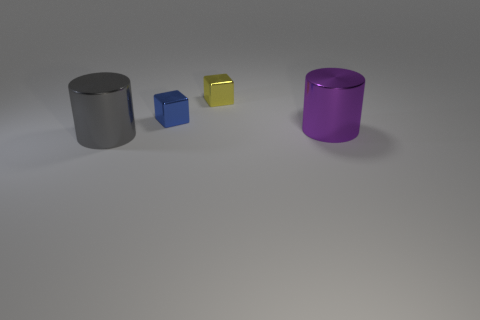What shape is the thing that is behind the big gray metallic thing and on the left side of the yellow cube?
Your answer should be very brief. Cube. There is a large metal object that is to the left of the blue shiny block; is it the same shape as the large metallic thing that is to the right of the blue thing?
Keep it short and to the point. Yes. What number of spheres are either big purple rubber things or purple things?
Offer a very short reply. 0. Is the number of yellow objects left of the tiny yellow block less than the number of big red balls?
Make the answer very short. No. How many other things are made of the same material as the gray thing?
Your response must be concise. 3. Does the gray object have the same size as the purple object?
Offer a terse response. Yes. What number of objects are large shiny cylinders that are left of the blue metal cube or big yellow rubber cubes?
Provide a succinct answer. 1. Are there any small yellow objects of the same shape as the gray shiny object?
Your answer should be compact. No. There is a purple metallic object; is its size the same as the cylinder that is in front of the large purple cylinder?
Ensure brevity in your answer.  Yes. What number of objects are either cylinders on the left side of the purple thing or cylinders that are on the left side of the purple cylinder?
Ensure brevity in your answer.  1. 